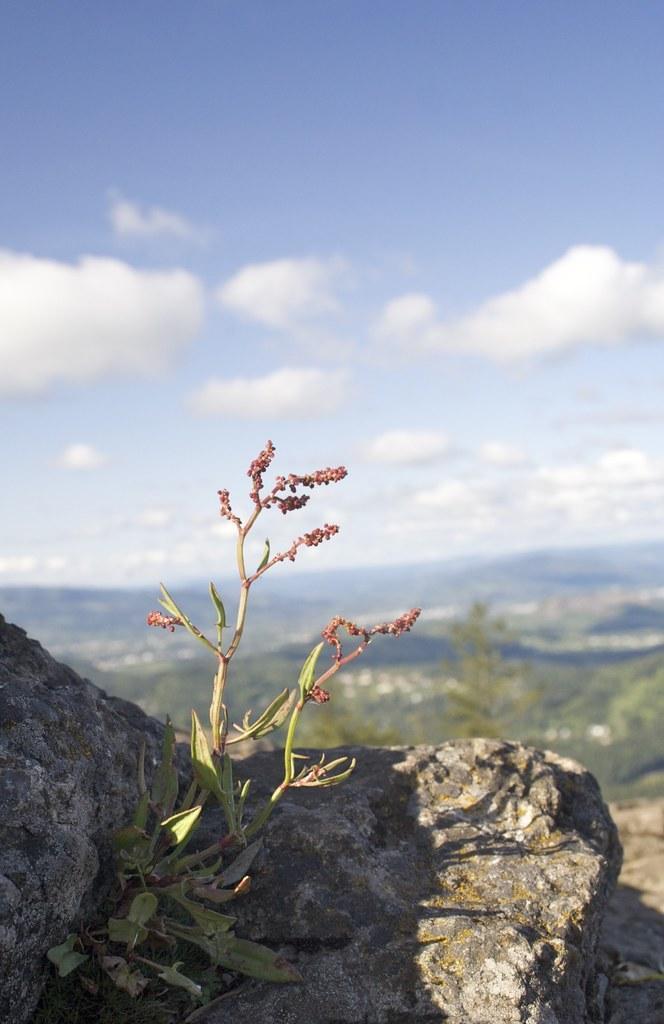Can you describe this image briefly? In this picture we can see a rock and a plant in the front, in the background there are some plants, we can see the sky and clouds at the top of the picture. 